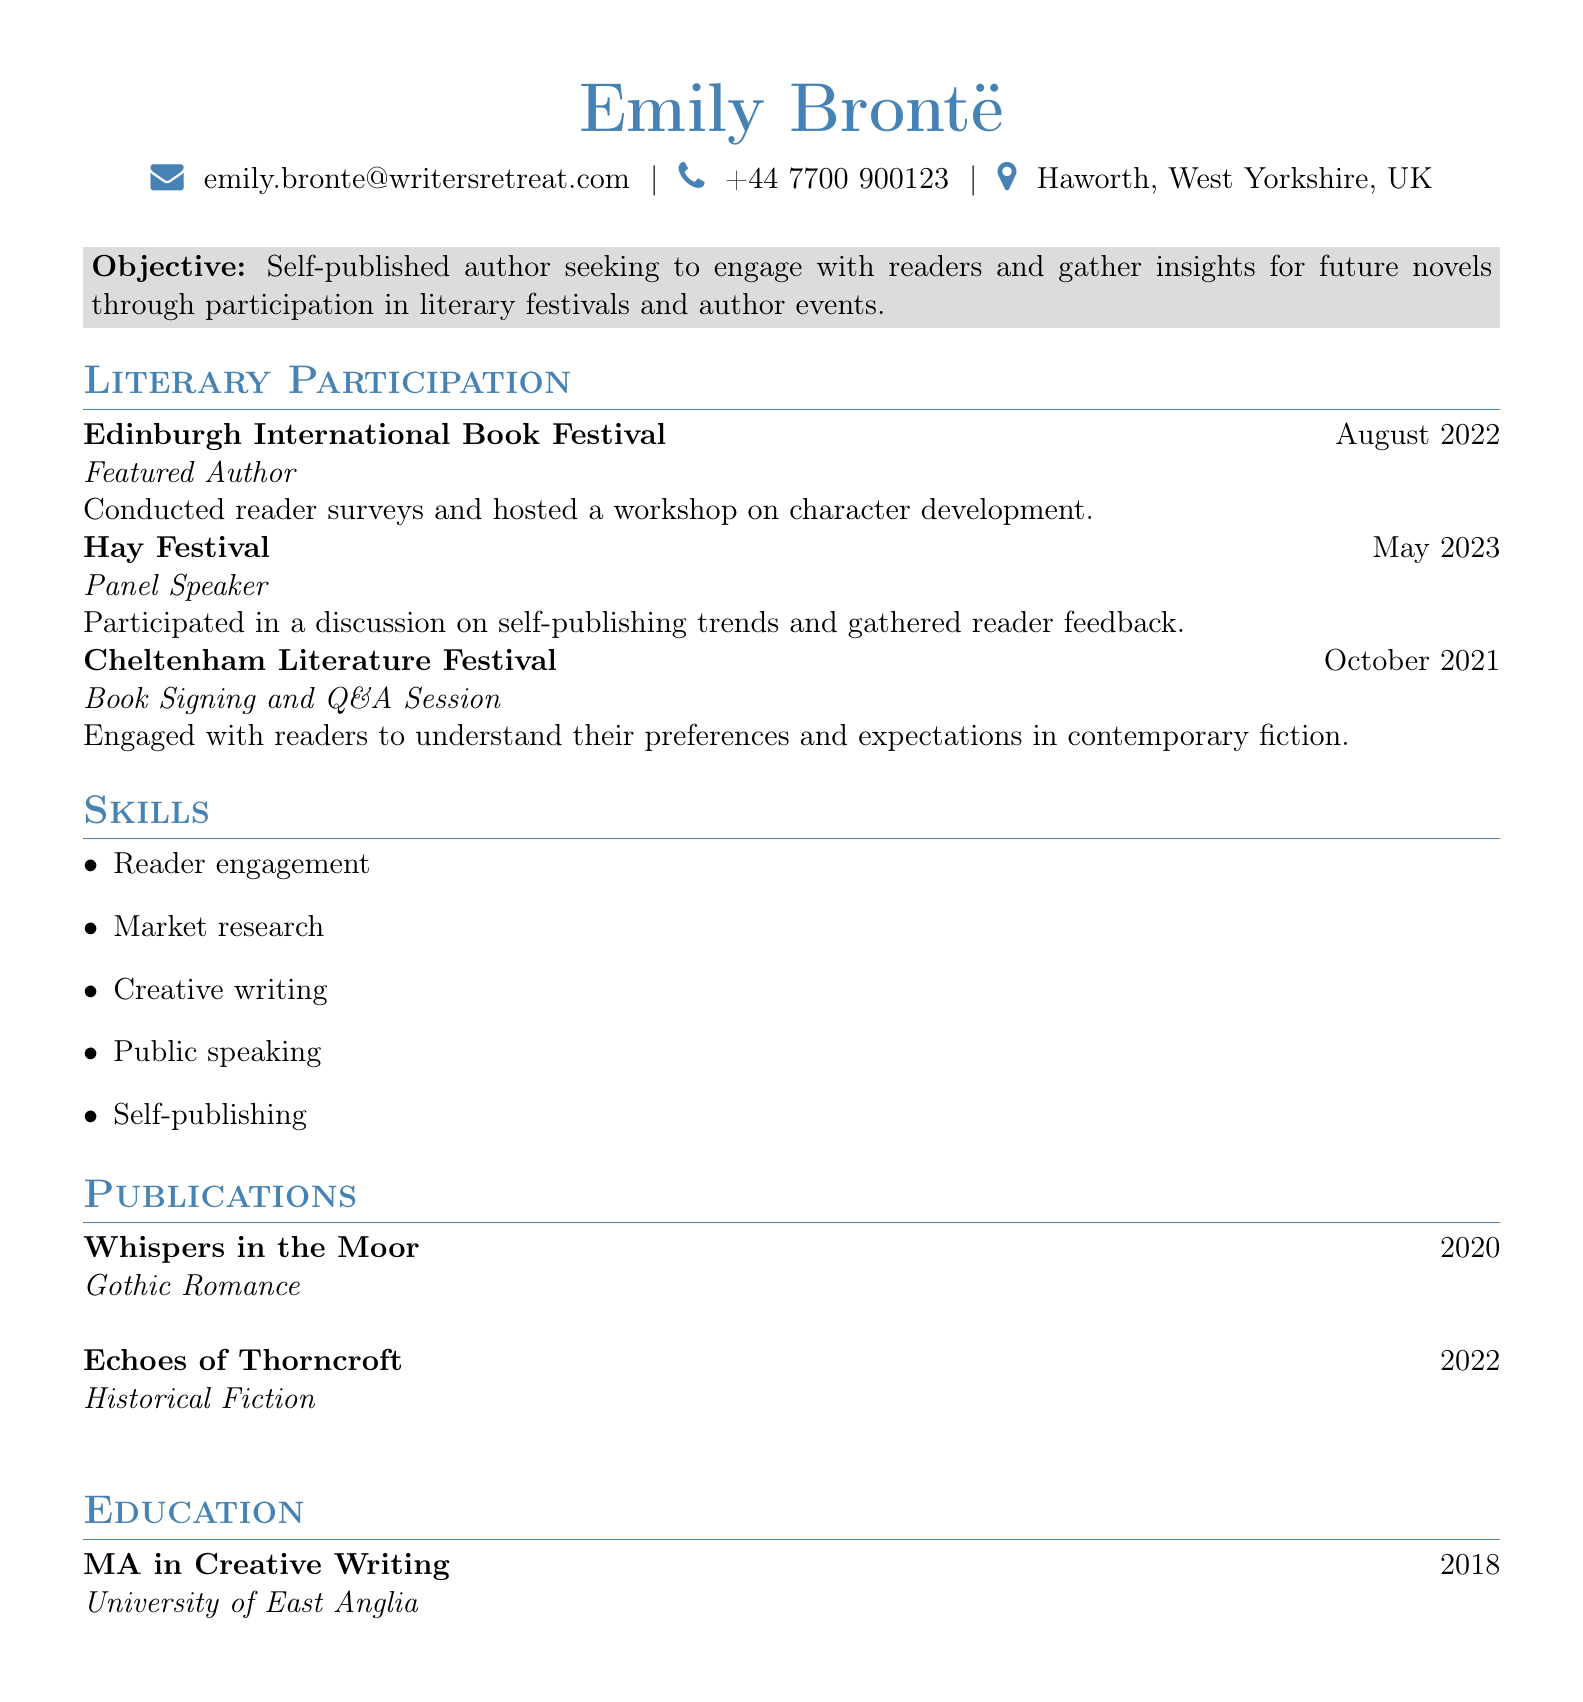What is the author's name? The author's name is listed at the top of the document.
Answer: Emily Brontë What is the email address provided? The email address is found in the personal information section of the document.
Answer: emily.bronte@writersretreat.com What role did Emily Brontë have at the Hay Festival? This information is stated under the literary participation section for that event.
Answer: Panel Speaker What date did the Cheltenham Literature Festival take place? This date is included with the event details in the document.
Answer: October 2021 Which publication is classified as Gothic Romance? The genre of each publication is specified in the publications section.
Answer: Whispers in the Moor What degree did Emily Brontë earn? The educational background is detailed at the end of the document.
Answer: MA in Creative Writing How many literary festivals did she participate in? This can be found by counting the events listed in the literary participation section.
Answer: 3 What skill is listed first in the skills section? The skills section outlines various competencies in a bulleted format.
Answer: Reader engagement Which year was "Echoes of Thorncroft" published? The publication date is provided for each of the listed works.
Answer: 2022 